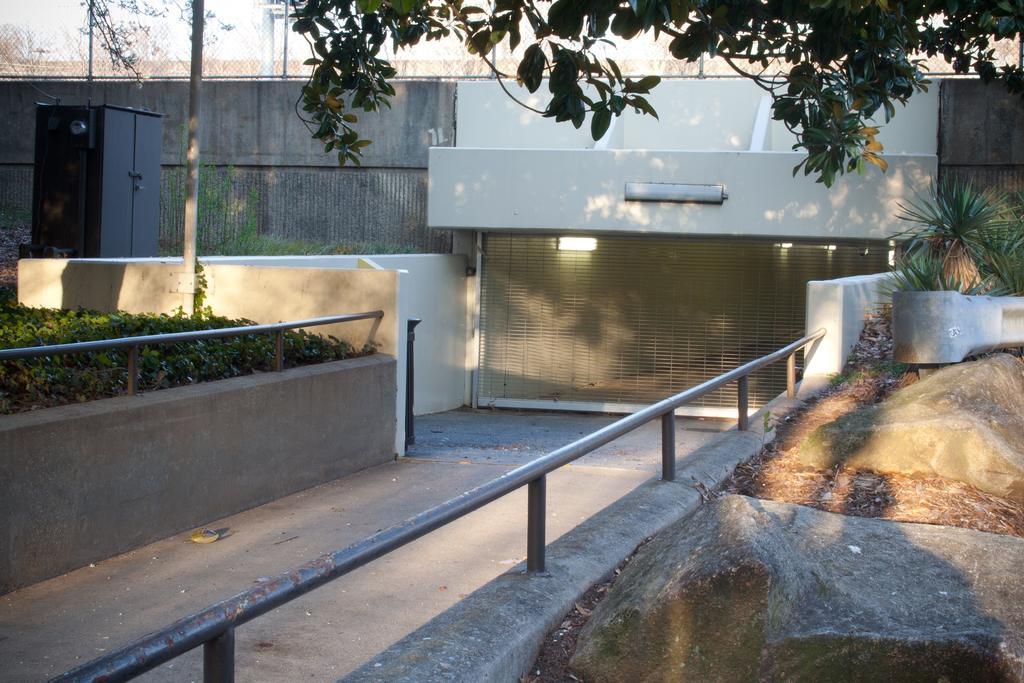How would you summarize this image in a sentence or two? In the image we can see some fencing, plants, trees, poles. 